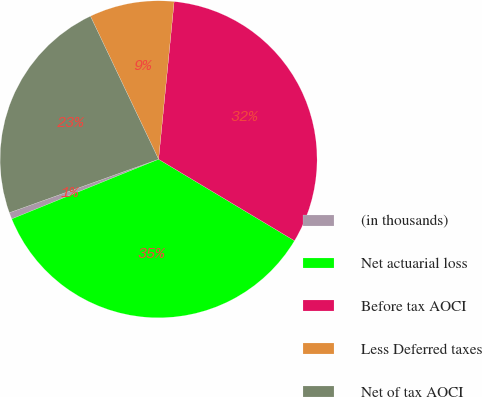Convert chart to OTSL. <chart><loc_0><loc_0><loc_500><loc_500><pie_chart><fcel>(in thousands)<fcel>Net actuarial loss<fcel>Before tax AOCI<fcel>Less Deferred taxes<fcel>Net of tax AOCI<nl><fcel>0.67%<fcel>35.26%<fcel>32.03%<fcel>8.64%<fcel>23.4%<nl></chart> 